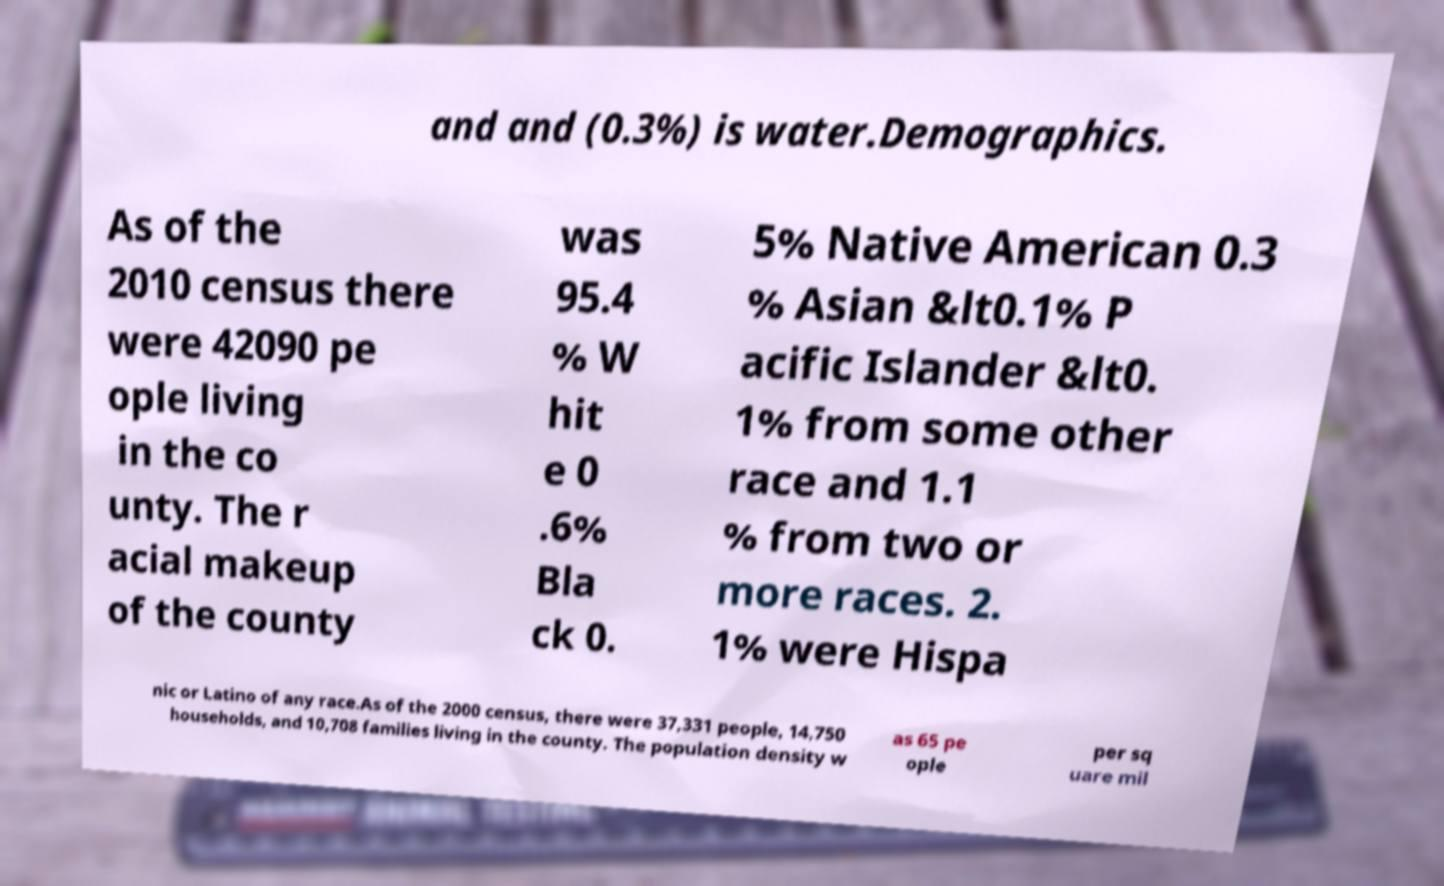Can you accurately transcribe the text from the provided image for me? and and (0.3%) is water.Demographics. As of the 2010 census there were 42090 pe ople living in the co unty. The r acial makeup of the county was 95.4 % W hit e 0 .6% Bla ck 0. 5% Native American 0.3 % Asian &lt0.1% P acific Islander &lt0. 1% from some other race and 1.1 % from two or more races. 2. 1% were Hispa nic or Latino of any race.As of the 2000 census, there were 37,331 people, 14,750 households, and 10,708 families living in the county. The population density w as 65 pe ople per sq uare mil 